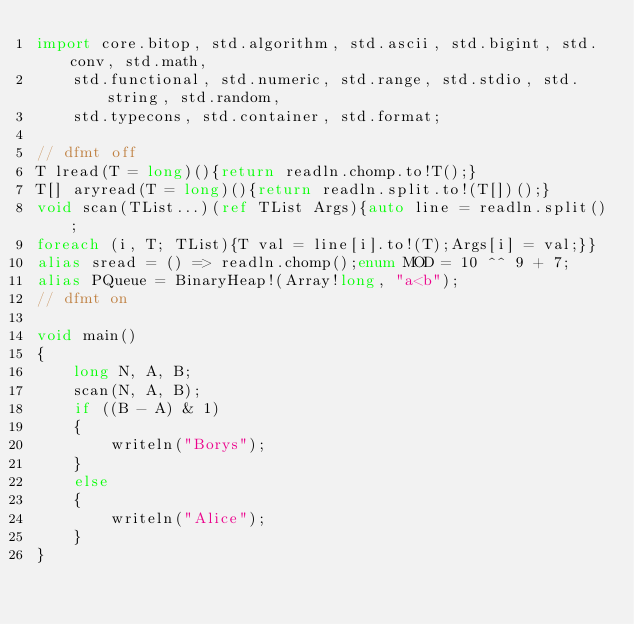<code> <loc_0><loc_0><loc_500><loc_500><_D_>import core.bitop, std.algorithm, std.ascii, std.bigint, std.conv, std.math,
    std.functional, std.numeric, std.range, std.stdio, std.string, std.random,
    std.typecons, std.container, std.format;

// dfmt off
T lread(T = long)(){return readln.chomp.to!T();}
T[] aryread(T = long)(){return readln.split.to!(T[])();}
void scan(TList...)(ref TList Args){auto line = readln.split();
foreach (i, T; TList){T val = line[i].to!(T);Args[i] = val;}}
alias sread = () => readln.chomp();enum MOD = 10 ^^ 9 + 7;
alias PQueue = BinaryHeap!(Array!long, "a<b");
// dfmt on

void main()
{
    long N, A, B;
    scan(N, A, B);
    if ((B - A) & 1)
    {
        writeln("Borys");
    }
    else
    {
        writeln("Alice");
    }
}
</code> 